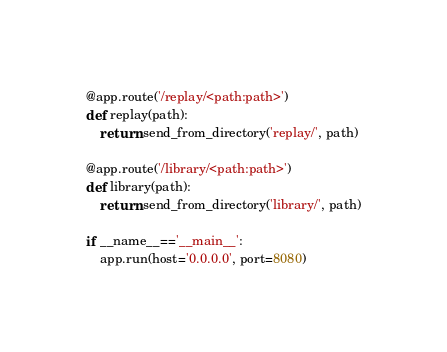<code> <loc_0><loc_0><loc_500><loc_500><_Python_>
@app.route('/replay/<path:path>')
def replay(path):
    return send_from_directory('replay/', path)

@app.route('/library/<path:path>')
def library(path):
    return send_from_directory('library/', path)

if __name__=='__main__':
    app.run(host='0.0.0.0', port=8080)</code> 